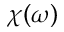Convert formula to latex. <formula><loc_0><loc_0><loc_500><loc_500>\chi ( \omega )</formula> 